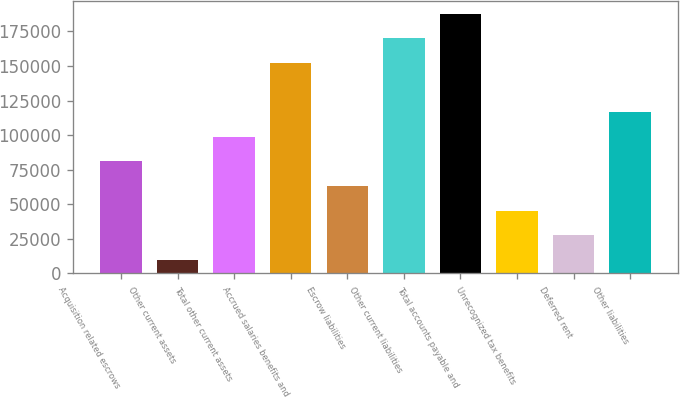<chart> <loc_0><loc_0><loc_500><loc_500><bar_chart><fcel>Acquisition related escrows<fcel>Other current assets<fcel>Total other current assets<fcel>Accrued salaries benefits and<fcel>Escrow liabilities<fcel>Other current liabilities<fcel>Total accounts payable and<fcel>Unrecognized tax benefits<fcel>Deferred rent<fcel>Other liabilities<nl><fcel>80958.4<fcel>9832<fcel>98740<fcel>152085<fcel>63176.8<fcel>169866<fcel>187648<fcel>45395.2<fcel>27613.6<fcel>116522<nl></chart> 